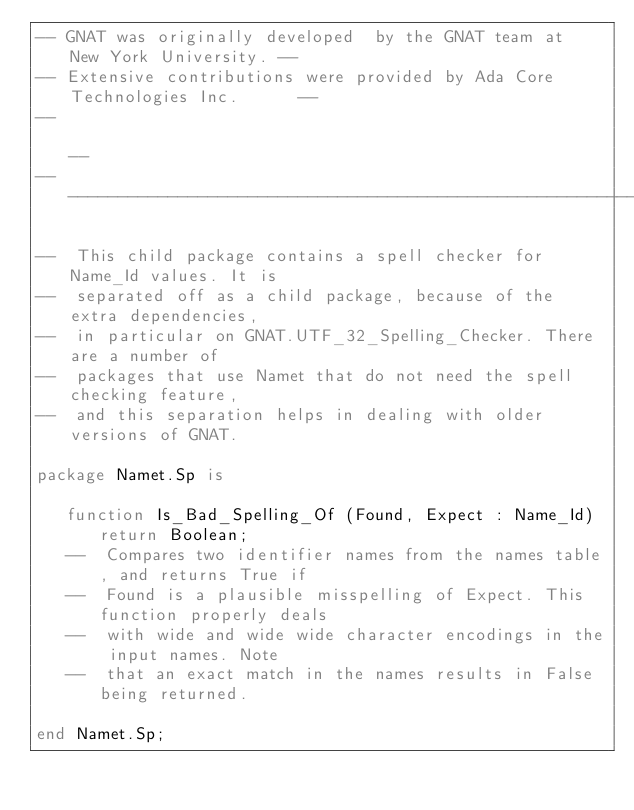<code> <loc_0><loc_0><loc_500><loc_500><_Ada_>-- GNAT was originally developed  by the GNAT team at  New York University. --
-- Extensive contributions were provided by Ada Core Technologies Inc.      --
--                                                                          --
------------------------------------------------------------------------------

--  This child package contains a spell checker for Name_Id values. It is
--  separated off as a child package, because of the extra dependencies,
--  in particular on GNAT.UTF_32_Spelling_Checker. There are a number of
--  packages that use Namet that do not need the spell checking feature,
--  and this separation helps in dealing with older versions of GNAT.

package Namet.Sp is

   function Is_Bad_Spelling_Of (Found, Expect : Name_Id) return Boolean;
   --  Compares two identifier names from the names table, and returns True if
   --  Found is a plausible misspelling of Expect. This function properly deals
   --  with wide and wide wide character encodings in the input names. Note
   --  that an exact match in the names results in False being returned.

end Namet.Sp;
</code> 